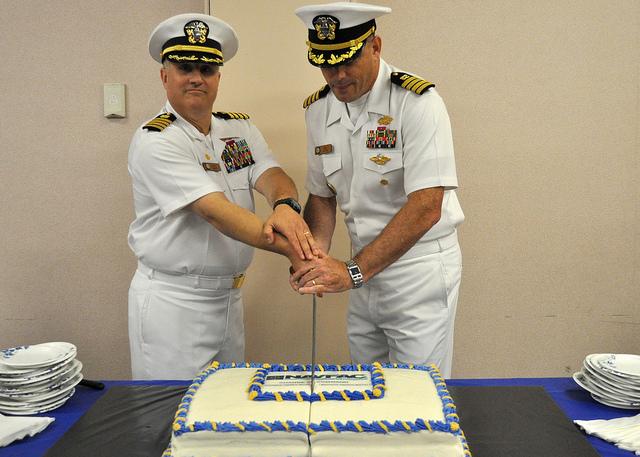What are the two men cutting?
Quick response, please. Cake. What is the man cutting?
Keep it brief. Cake. What color is the tablecloth?
Concise answer only. Black. What is he preparing?
Keep it brief. Cake. What are the men using to cut?
Be succinct. Knife. Are the two men related?
Write a very short answer. No. 